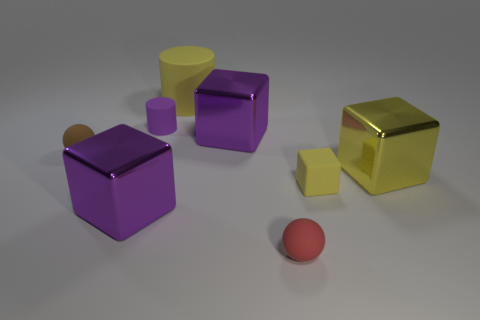Add 2 rubber balls. How many objects exist? 10 Subtract all spheres. How many objects are left? 6 Add 6 brown rubber things. How many brown rubber things exist? 7 Subtract 0 blue spheres. How many objects are left? 8 Subtract all spheres. Subtract all small things. How many objects are left? 2 Add 5 big metal blocks. How many big metal blocks are left? 8 